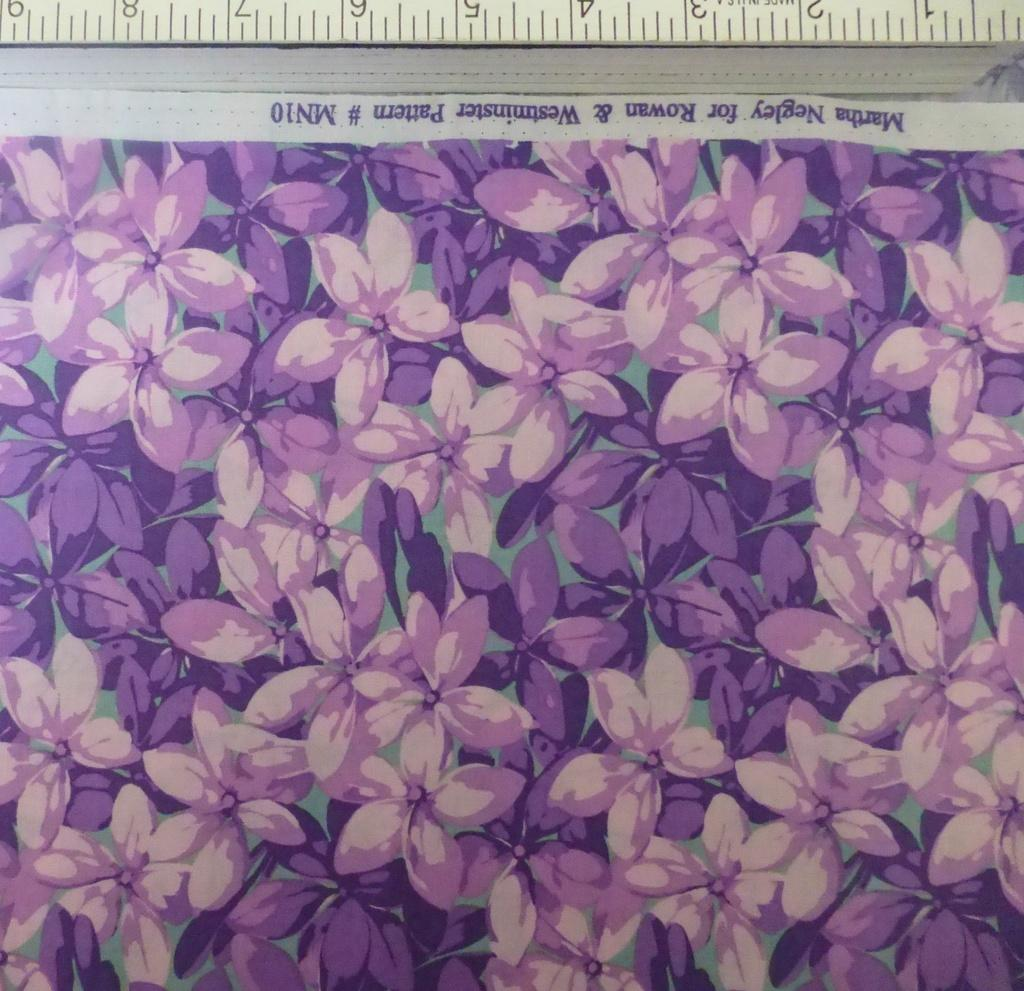<image>
Describe the image concisely. a purple print of flowers by Martha Wegley. 